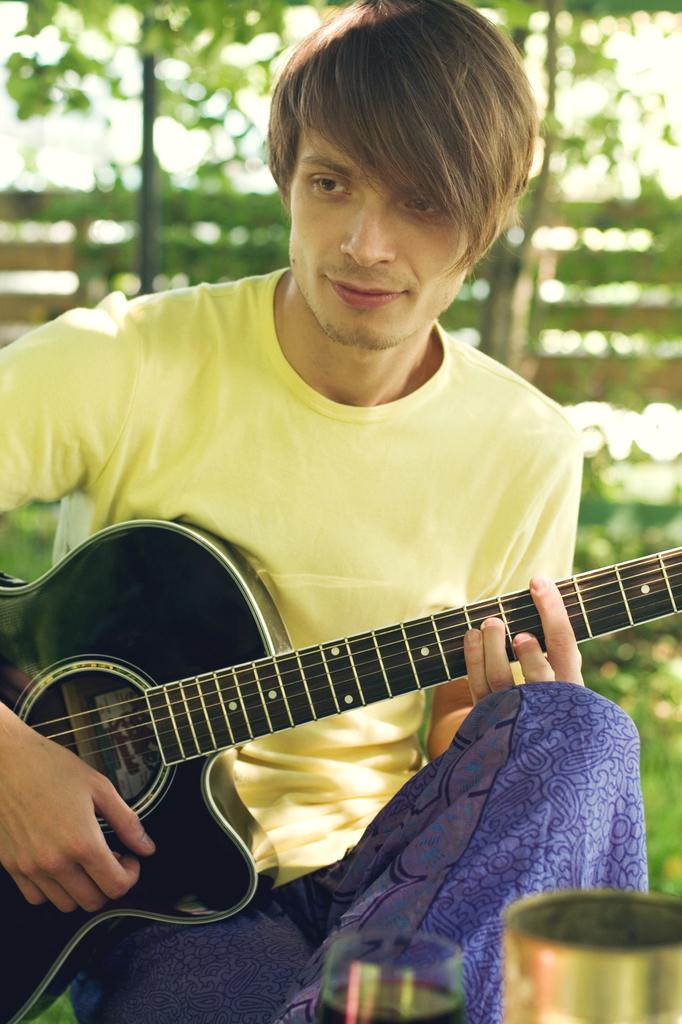Who is the main subject in the image? There is a man in the image. What is the man doing in the image? The man is sitting and playing a guitar. What type of spark can be seen coming from the guitar in the image? There is no spark visible in the image; the man is simply playing the guitar. 